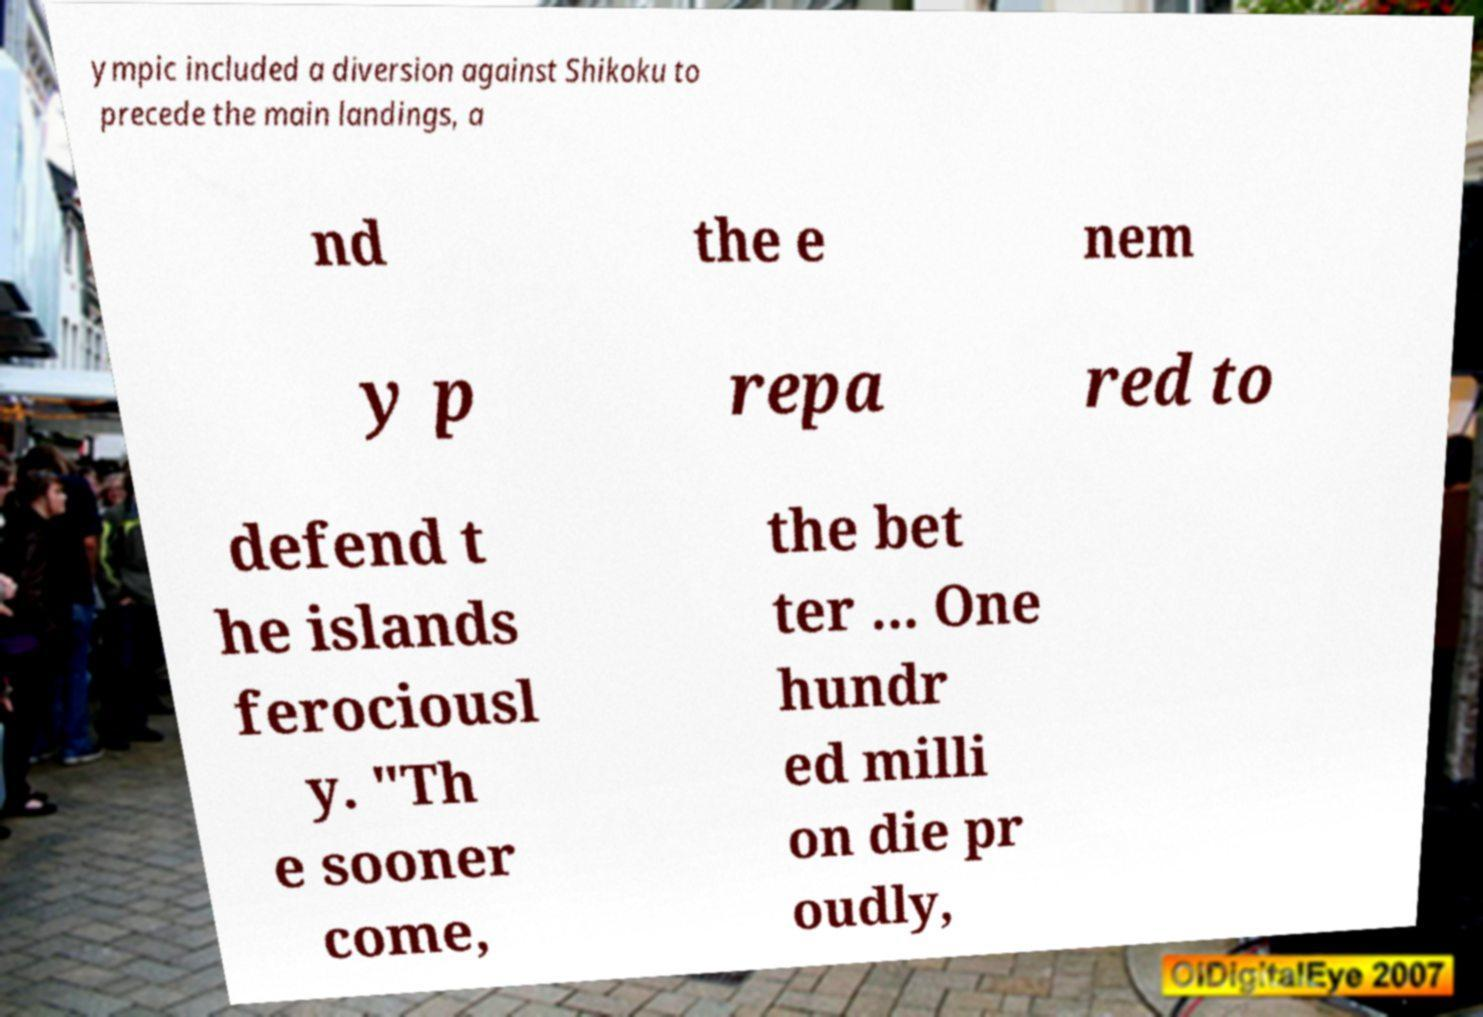Could you extract and type out the text from this image? ympic included a diversion against Shikoku to precede the main landings, a nd the e nem y p repa red to defend t he islands ferociousl y. "Th e sooner come, the bet ter ... One hundr ed milli on die pr oudly, 